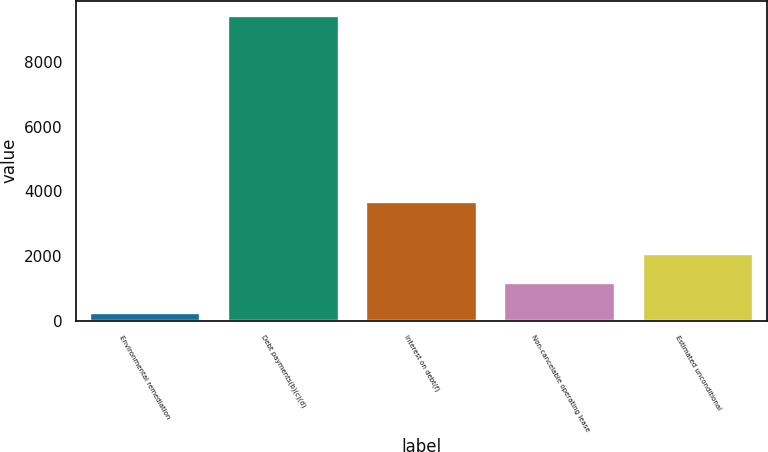<chart> <loc_0><loc_0><loc_500><loc_500><bar_chart><fcel>Environmental remediation<fcel>Debt payments(b)(c)(d)<fcel>Interest on debt(f)<fcel>Non-cancelable operating lease<fcel>Estimated unconditional<nl><fcel>246<fcel>9415<fcel>3684<fcel>1162.9<fcel>2079.8<nl></chart> 